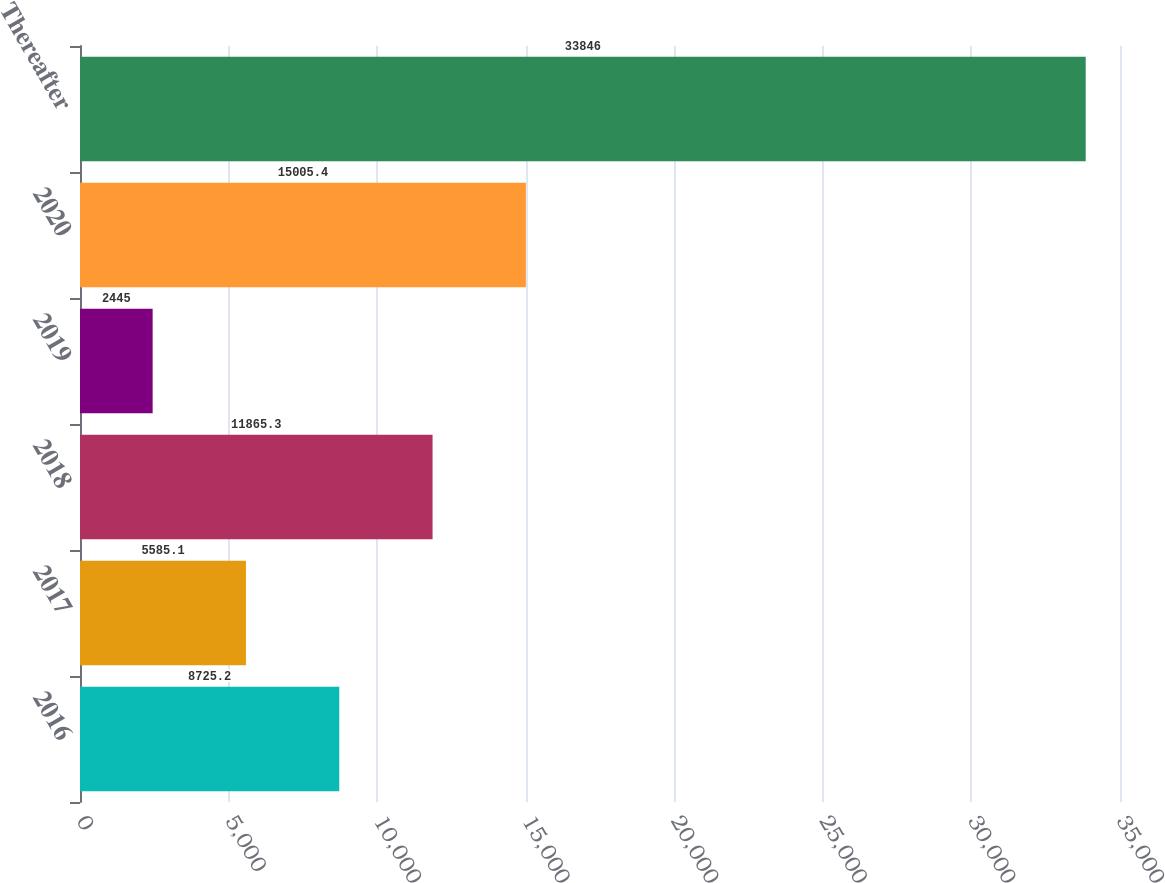Convert chart to OTSL. <chart><loc_0><loc_0><loc_500><loc_500><bar_chart><fcel>2016<fcel>2017<fcel>2018<fcel>2019<fcel>2020<fcel>Thereafter<nl><fcel>8725.2<fcel>5585.1<fcel>11865.3<fcel>2445<fcel>15005.4<fcel>33846<nl></chart> 